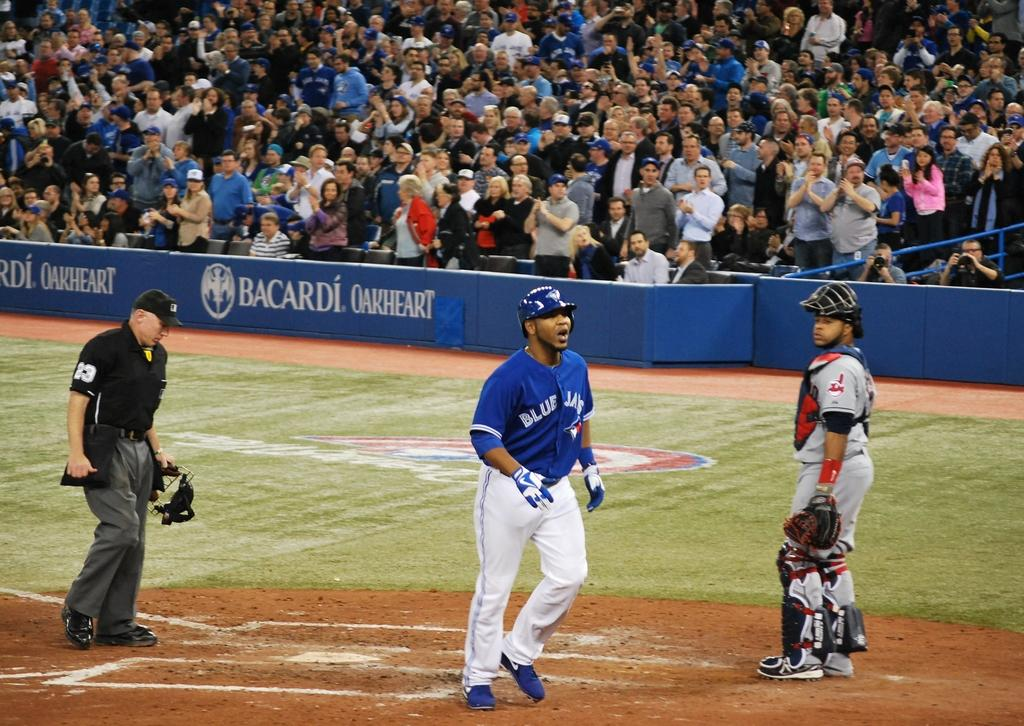<image>
Present a compact description of the photo's key features. A baseball player for the Blue Jay's is standing near a base. 